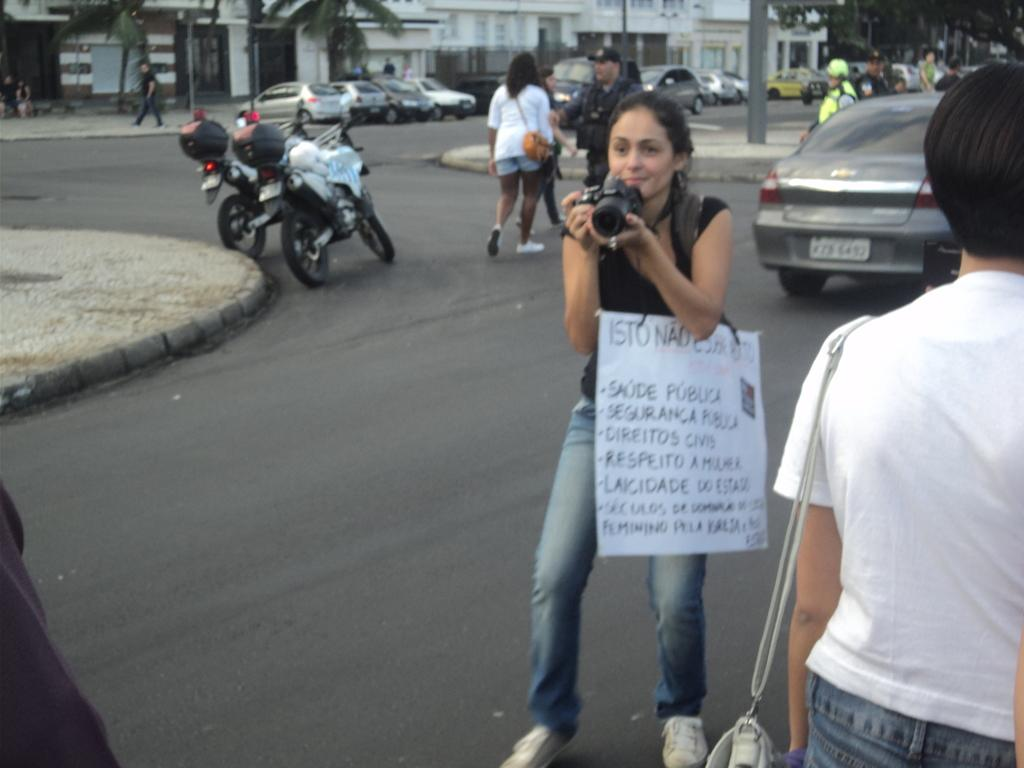What is the woman holding in the image? The woman is holding a camera. What is the woman wearing in the image? The woman is wearing a poster. What can be seen in the background of the image? There are vehicles, buildings, trees, and a pole in the background. How many bricks are visible on the woman's poster in the image? There is no mention of bricks in the image, and the woman is wearing a poster, not a brick structure. Are the woman's sisters present in the image? There is no mention of sisters in the image, and the focus is on the woman holding a camera and wearing a poster. 